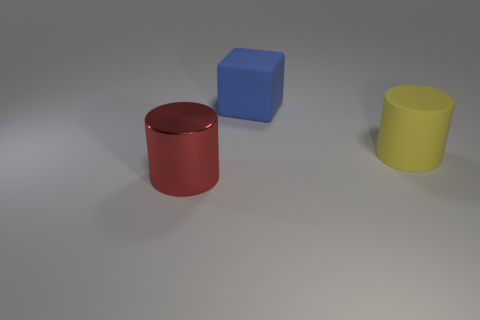Add 3 small purple cylinders. How many objects exist? 6 Subtract all cubes. How many objects are left? 2 Add 1 large blue things. How many large blue things are left? 2 Add 2 small green spheres. How many small green spheres exist? 2 Subtract 0 gray blocks. How many objects are left? 3 Subtract all yellow matte cylinders. Subtract all large matte blocks. How many objects are left? 1 